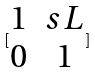Convert formula to latex. <formula><loc_0><loc_0><loc_500><loc_500>[ \begin{matrix} 1 & s L \\ 0 & 1 \end{matrix} ]</formula> 